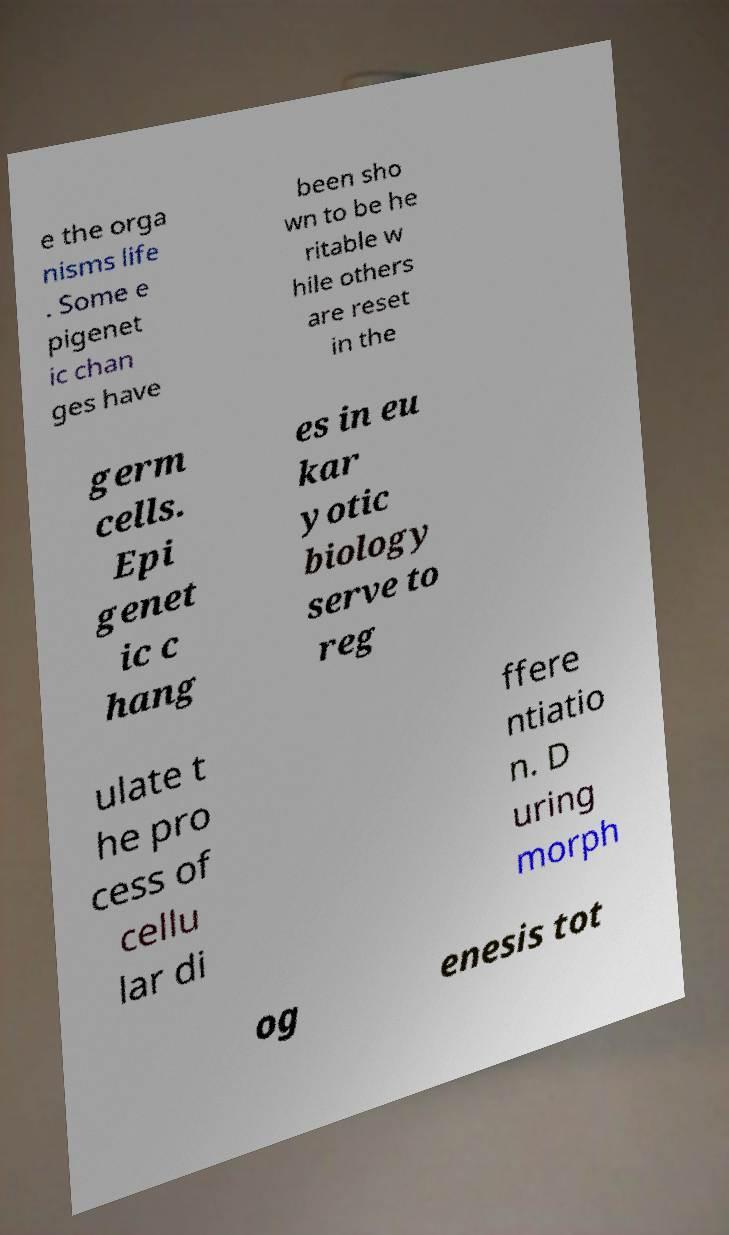Can you read and provide the text displayed in the image?This photo seems to have some interesting text. Can you extract and type it out for me? e the orga nisms life . Some e pigenet ic chan ges have been sho wn to be he ritable w hile others are reset in the germ cells. Epi genet ic c hang es in eu kar yotic biology serve to reg ulate t he pro cess of cellu lar di ffere ntiatio n. D uring morph og enesis tot 